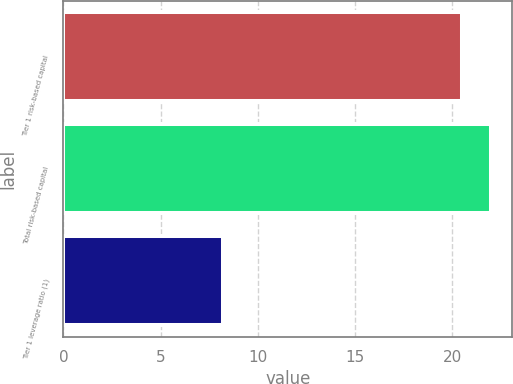<chart> <loc_0><loc_0><loc_500><loc_500><bar_chart><fcel>Tier 1 risk-based capital<fcel>Total risk-based capital<fcel>Tier 1 leverage ratio (1)<nl><fcel>20.5<fcel>22<fcel>8.2<nl></chart> 